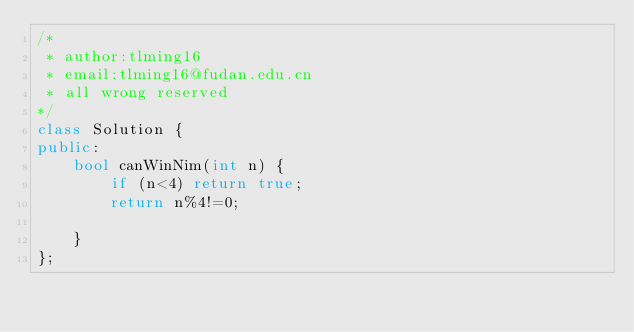Convert code to text. <code><loc_0><loc_0><loc_500><loc_500><_C++_>/* 
 * author:tlming16
 * email:tlming16@fudan.edu.cn
 * all wrong reserved
*/
class Solution {
public:
    bool canWinNim(int n) {
        if (n<4) return true;
        return n%4!=0;

    }
};</code> 